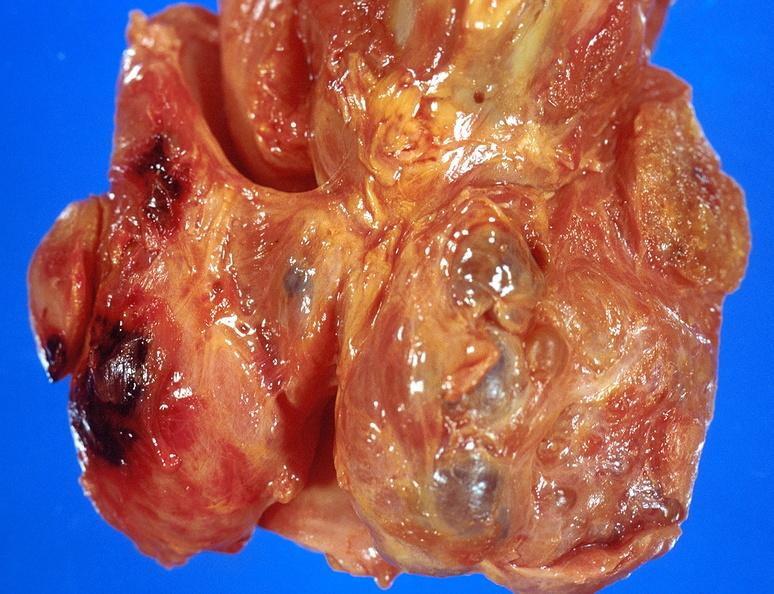does this image show thyroid, goiter?
Answer the question using a single word or phrase. Yes 